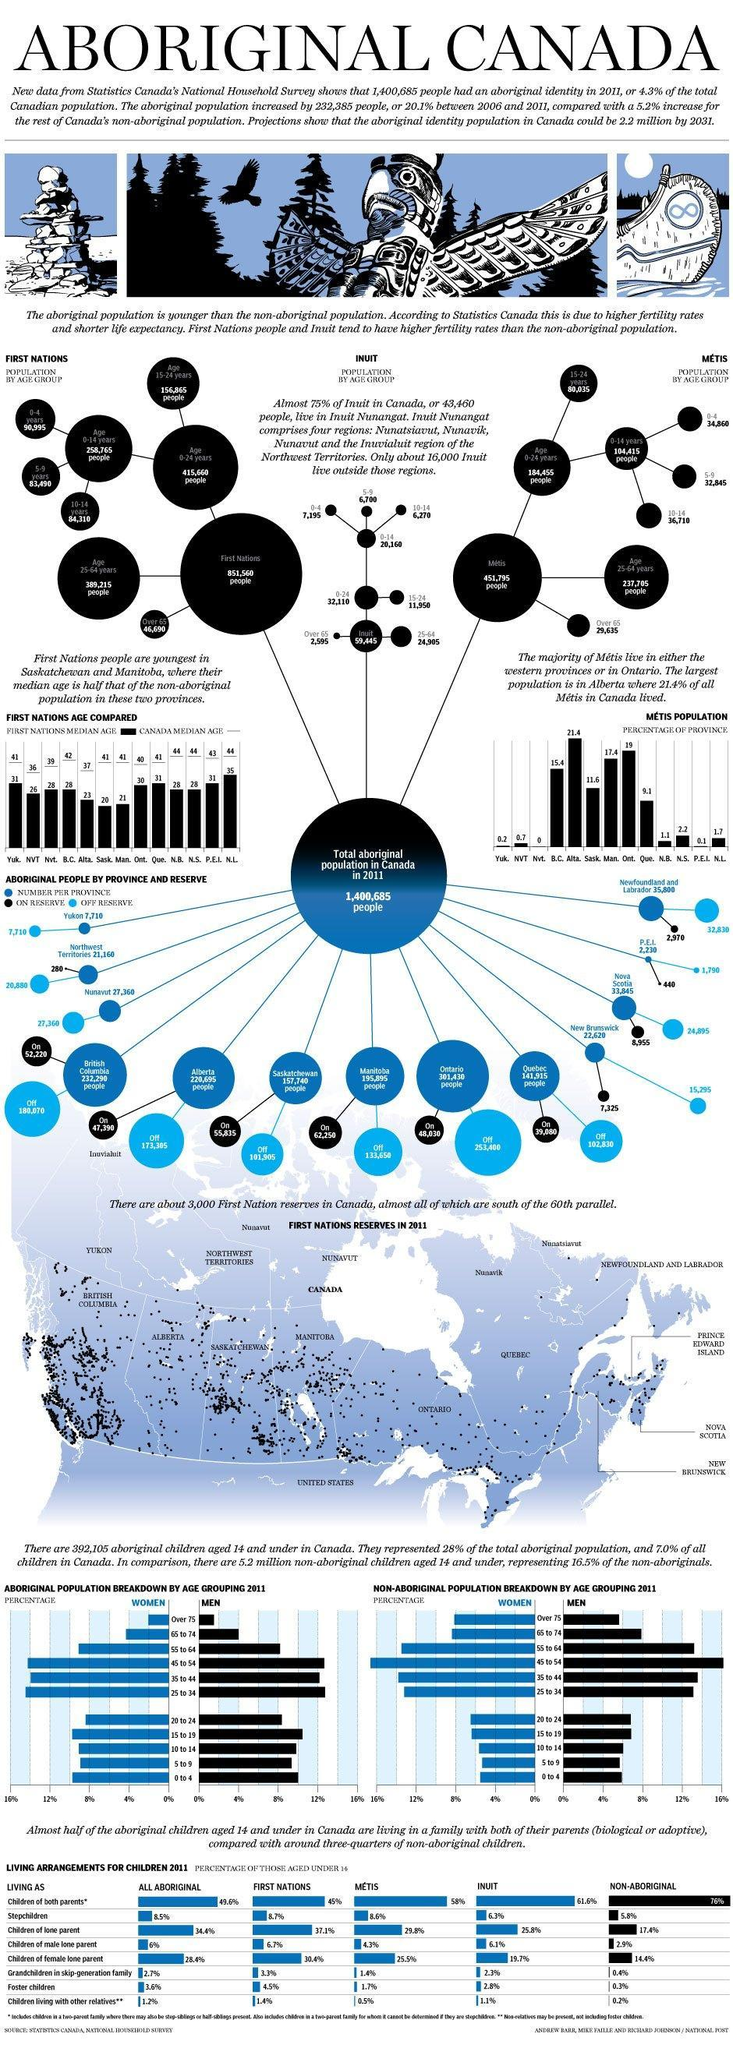How many aboriginal people from British Columbia are off-reserve in 2011?
Answer the question with a short phrase. 180,070 What is the population of the First Nations in Canada in 2011? 851,560 Which Canadian state has the second-highest aboriginal population in 2011? British Columbia What is the median age of the Quebec population in 2011? 41 How many Inuit people are in the age group of 15-24 years in Canada in 2011? 11,950 What is the age of the majority of the First Nations population in Canada in 2011? 0-24 years What is the median age of the First Nations population in Ontario in 2011? 30 What is the number of aboriginal people in Quebec in 2011? 141,915 Which Canadian state has the highest aboriginal population in 2011? Ontario How many aboriginal people from Alberta are on-reserve in 2011? 47,390 